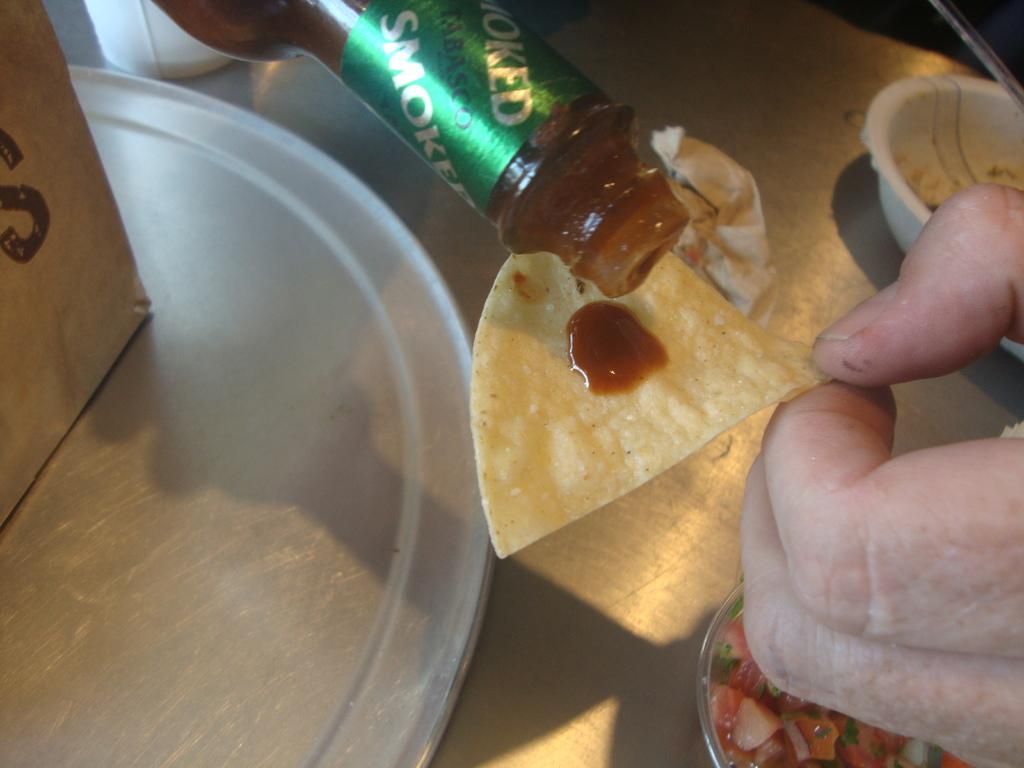<image>
Present a compact description of the photo's key features. Someone pouring smoked Tabasco hot sauce on a chip 